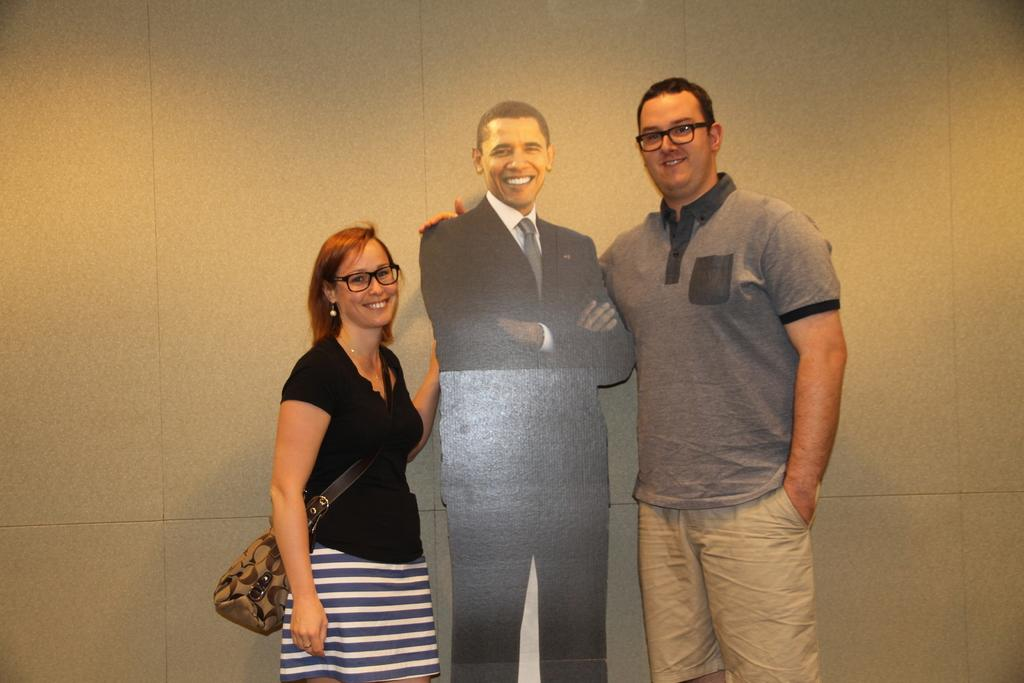How many people are in the image? There are two people in the image, a man and a woman. What are the man and the woman doing in the image? Both the man and the woman are standing and smiling. What can be seen on the board in the image? There is a board of a person in the image. What is visible in the background of the image? There is a wall in the background of the image. What type of songs can be heard coming from the notebook in the image? There is no notebook present in the image, and therefore no songs can be heard. 